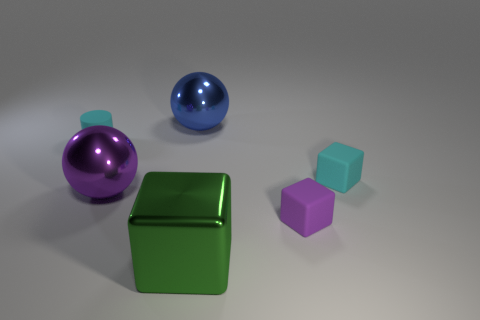What size is the matte block that is the same color as the tiny cylinder?
Keep it short and to the point. Small. How many large blue balls are on the left side of the big metal ball that is in front of the small object that is on the left side of the green shiny thing?
Offer a terse response. 0. There is a metal object that is on the right side of the big blue metallic object; is it the same size as the cyan object that is in front of the tiny cyan cylinder?
Offer a very short reply. No. What is the big sphere that is behind the cyan object behind the cyan cube made of?
Provide a short and direct response. Metal. How many objects are either small objects that are in front of the cyan rubber block or small brown cylinders?
Provide a short and direct response. 1. Are there the same number of purple metal things right of the cyan cube and large green cubes behind the big blue metal sphere?
Make the answer very short. Yes. The tiny thing that is in front of the metallic sphere that is in front of the matte object to the left of the purple metal sphere is made of what material?
Ensure brevity in your answer.  Rubber. There is a thing that is both in front of the cyan matte block and on the left side of the green metallic block; what is its size?
Ensure brevity in your answer.  Large. Does the small purple thing have the same shape as the blue metal thing?
Provide a short and direct response. No. What shape is the purple object that is the same material as the small cylinder?
Give a very brief answer. Cube. 